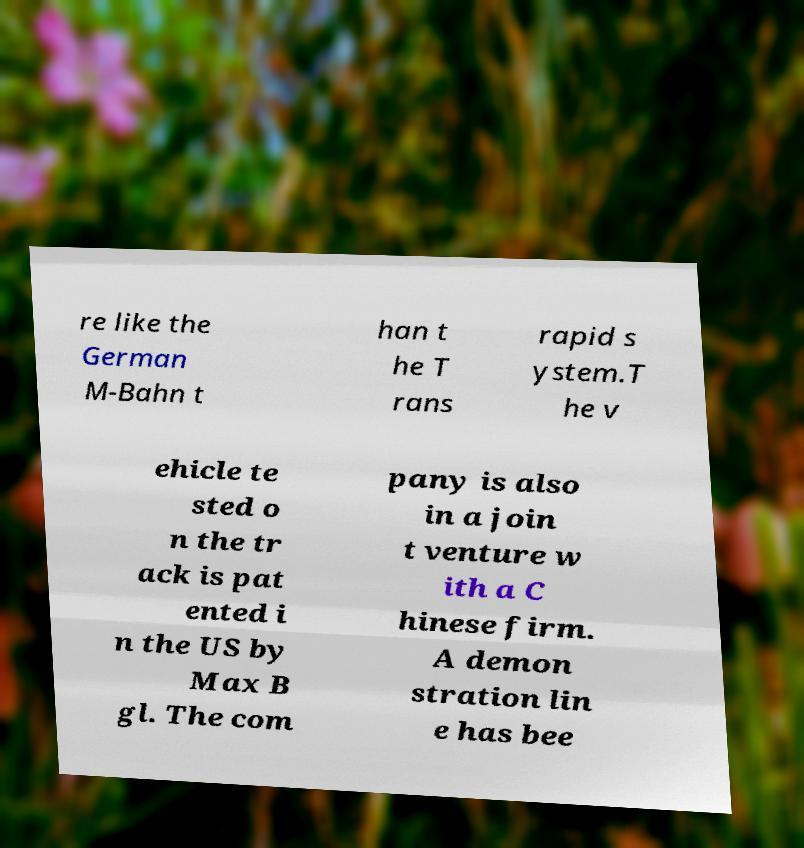Could you extract and type out the text from this image? re like the German M-Bahn t han t he T rans rapid s ystem.T he v ehicle te sted o n the tr ack is pat ented i n the US by Max B gl. The com pany is also in a join t venture w ith a C hinese firm. A demon stration lin e has bee 